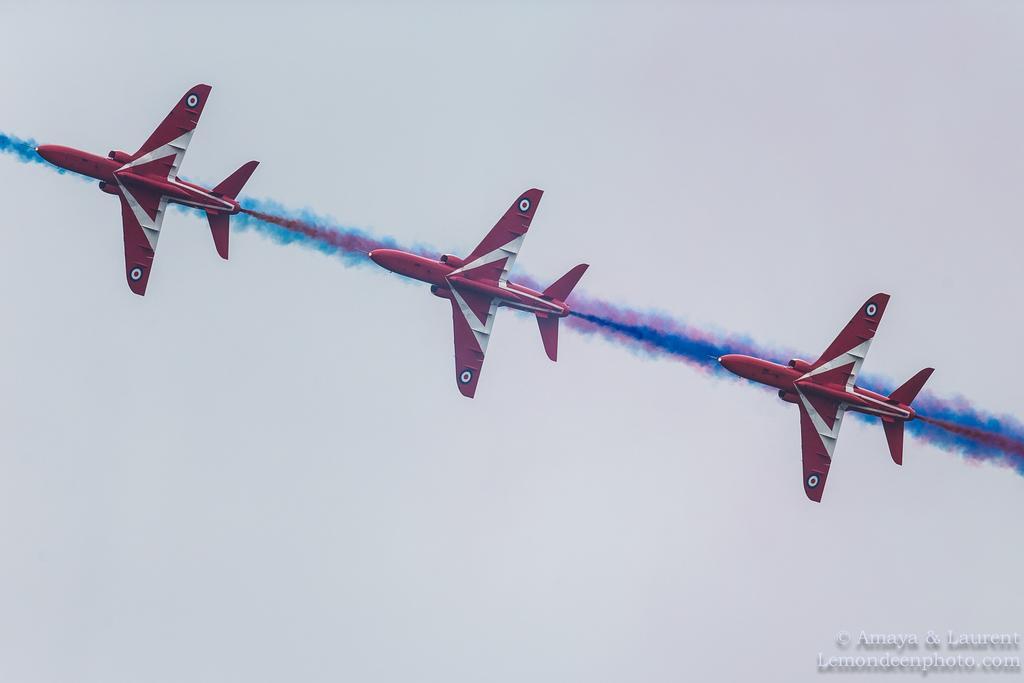Describe this image in one or two sentences. In this picture we can see three jet planes flying in the air, we can see smoke here, in the background there is the sky, at the right bottom we can see some text. 